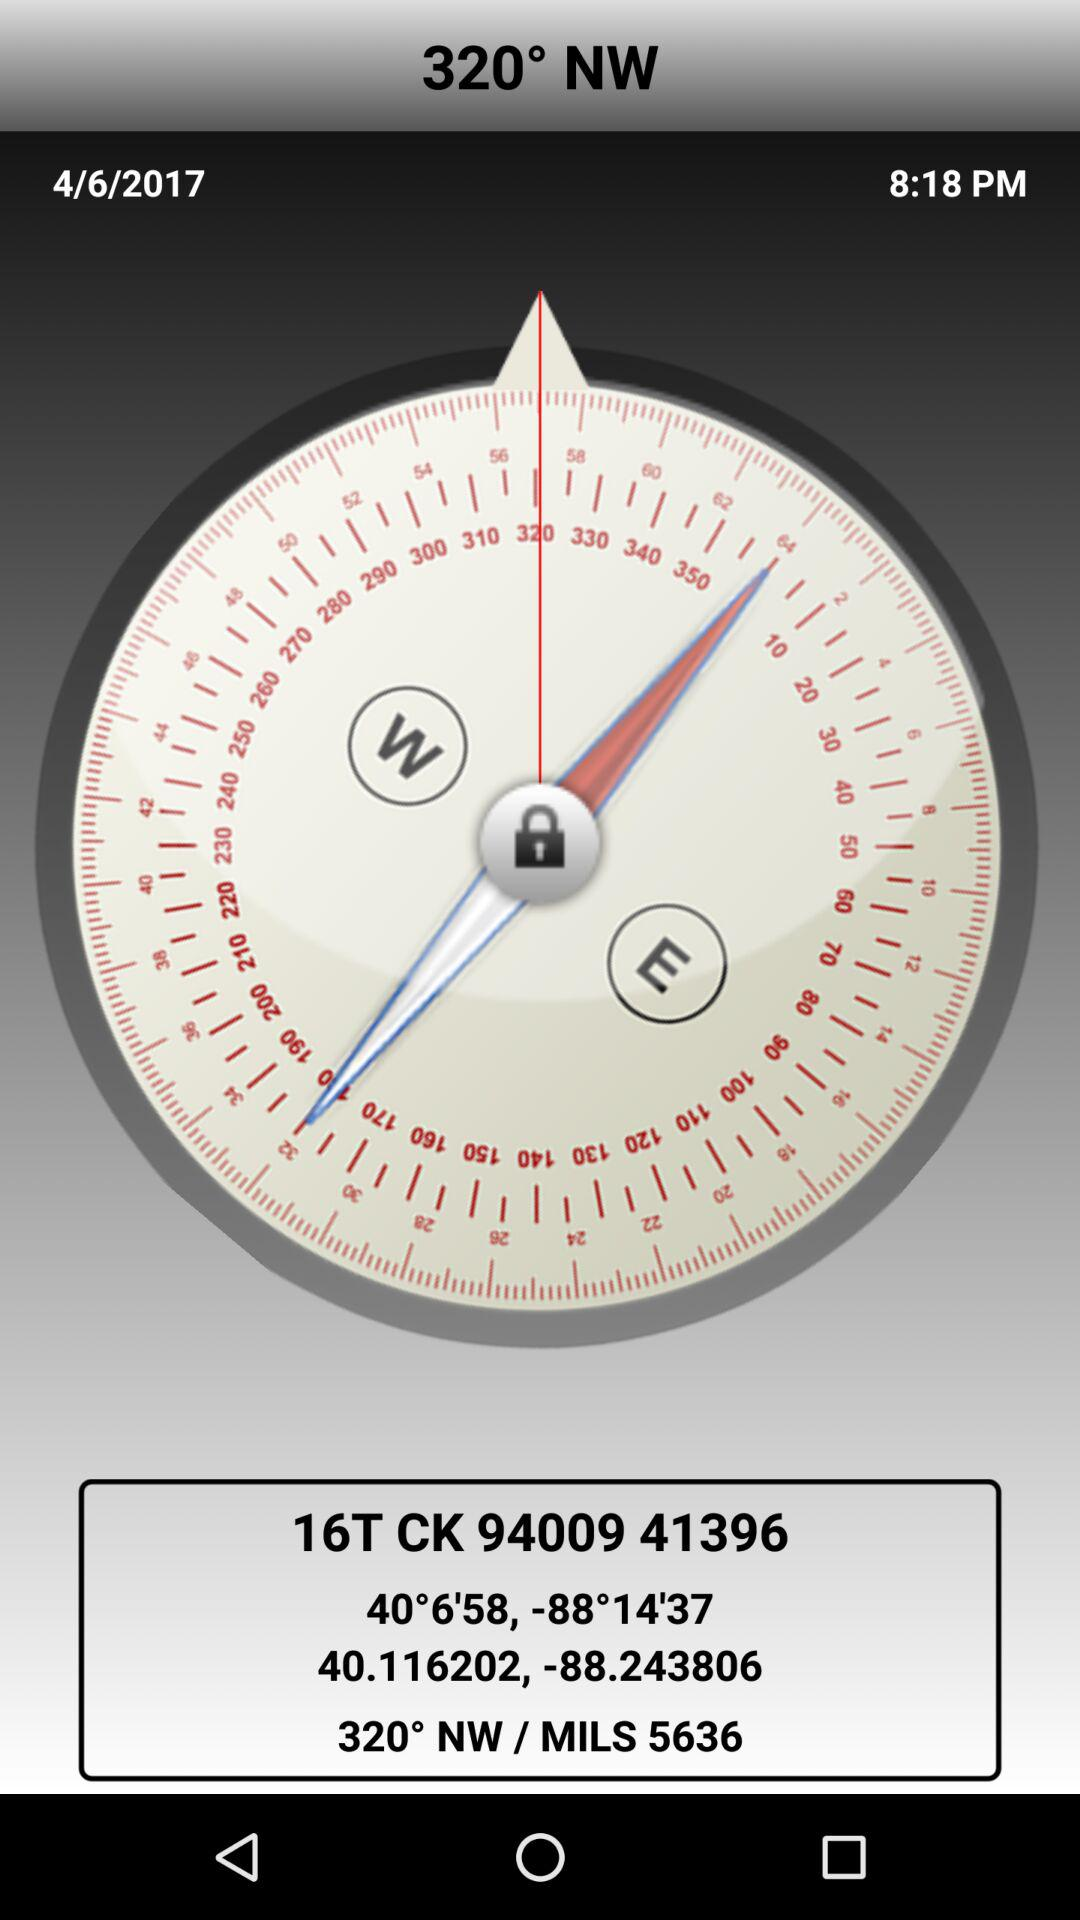What is the mentioned date? The mentioned date is April 6, 2017. 